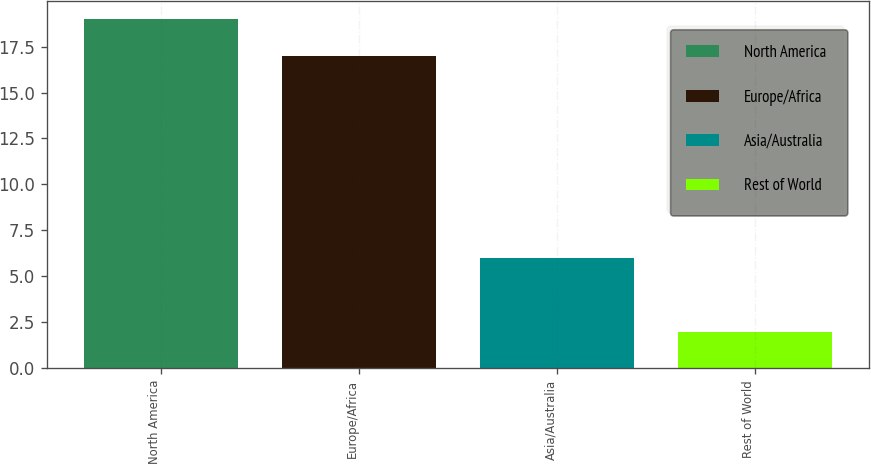Convert chart. <chart><loc_0><loc_0><loc_500><loc_500><bar_chart><fcel>North America<fcel>Europe/Africa<fcel>Asia/Australia<fcel>Rest of World<nl><fcel>19<fcel>17<fcel>6<fcel>2<nl></chart> 